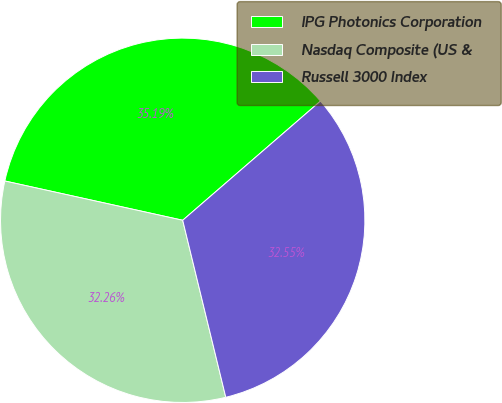Convert chart. <chart><loc_0><loc_0><loc_500><loc_500><pie_chart><fcel>IPG Photonics Corporation<fcel>Nasdaq Composite (US &<fcel>Russell 3000 Index<nl><fcel>35.19%<fcel>32.26%<fcel>32.55%<nl></chart> 